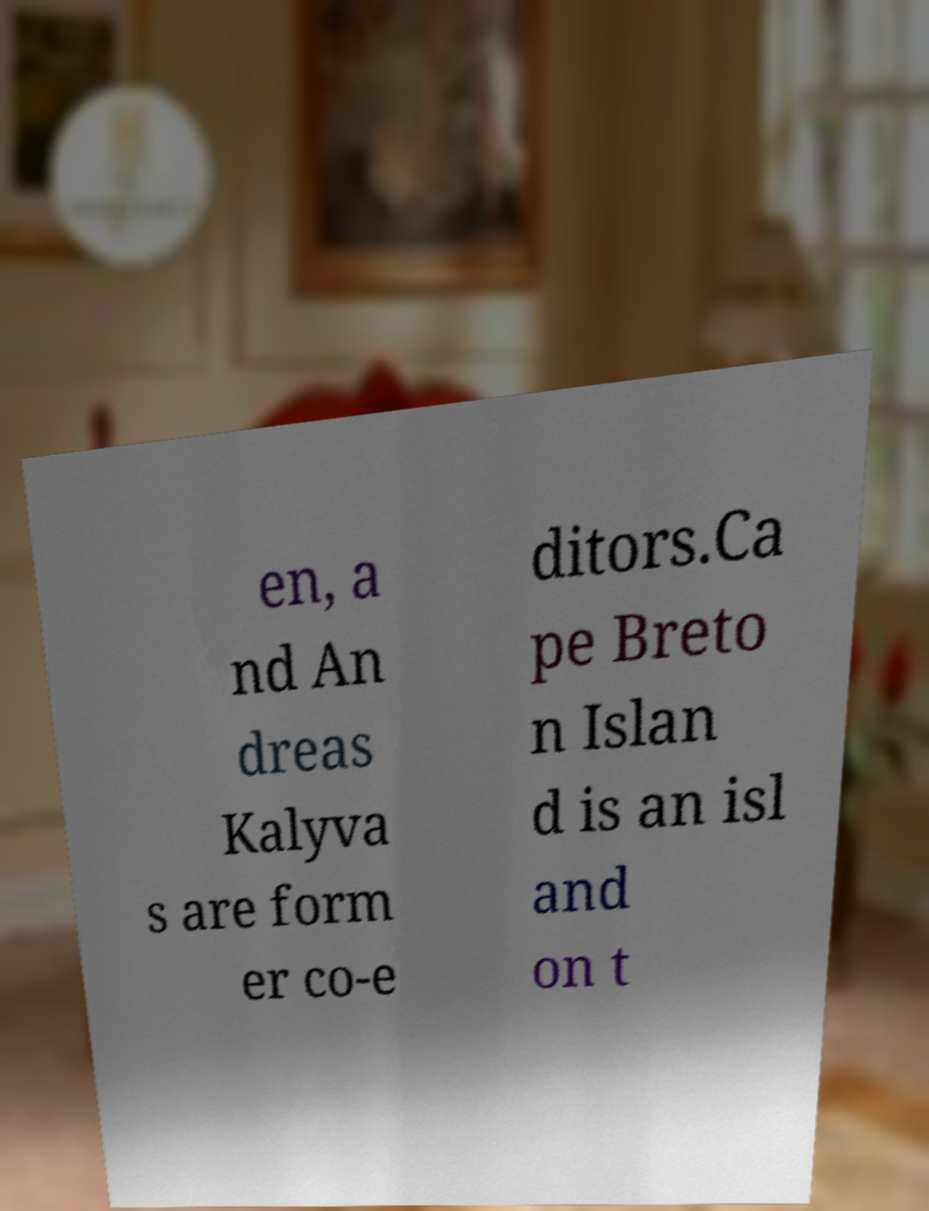I need the written content from this picture converted into text. Can you do that? en, a nd An dreas Kalyva s are form er co-e ditors.Ca pe Breto n Islan d is an isl and on t 